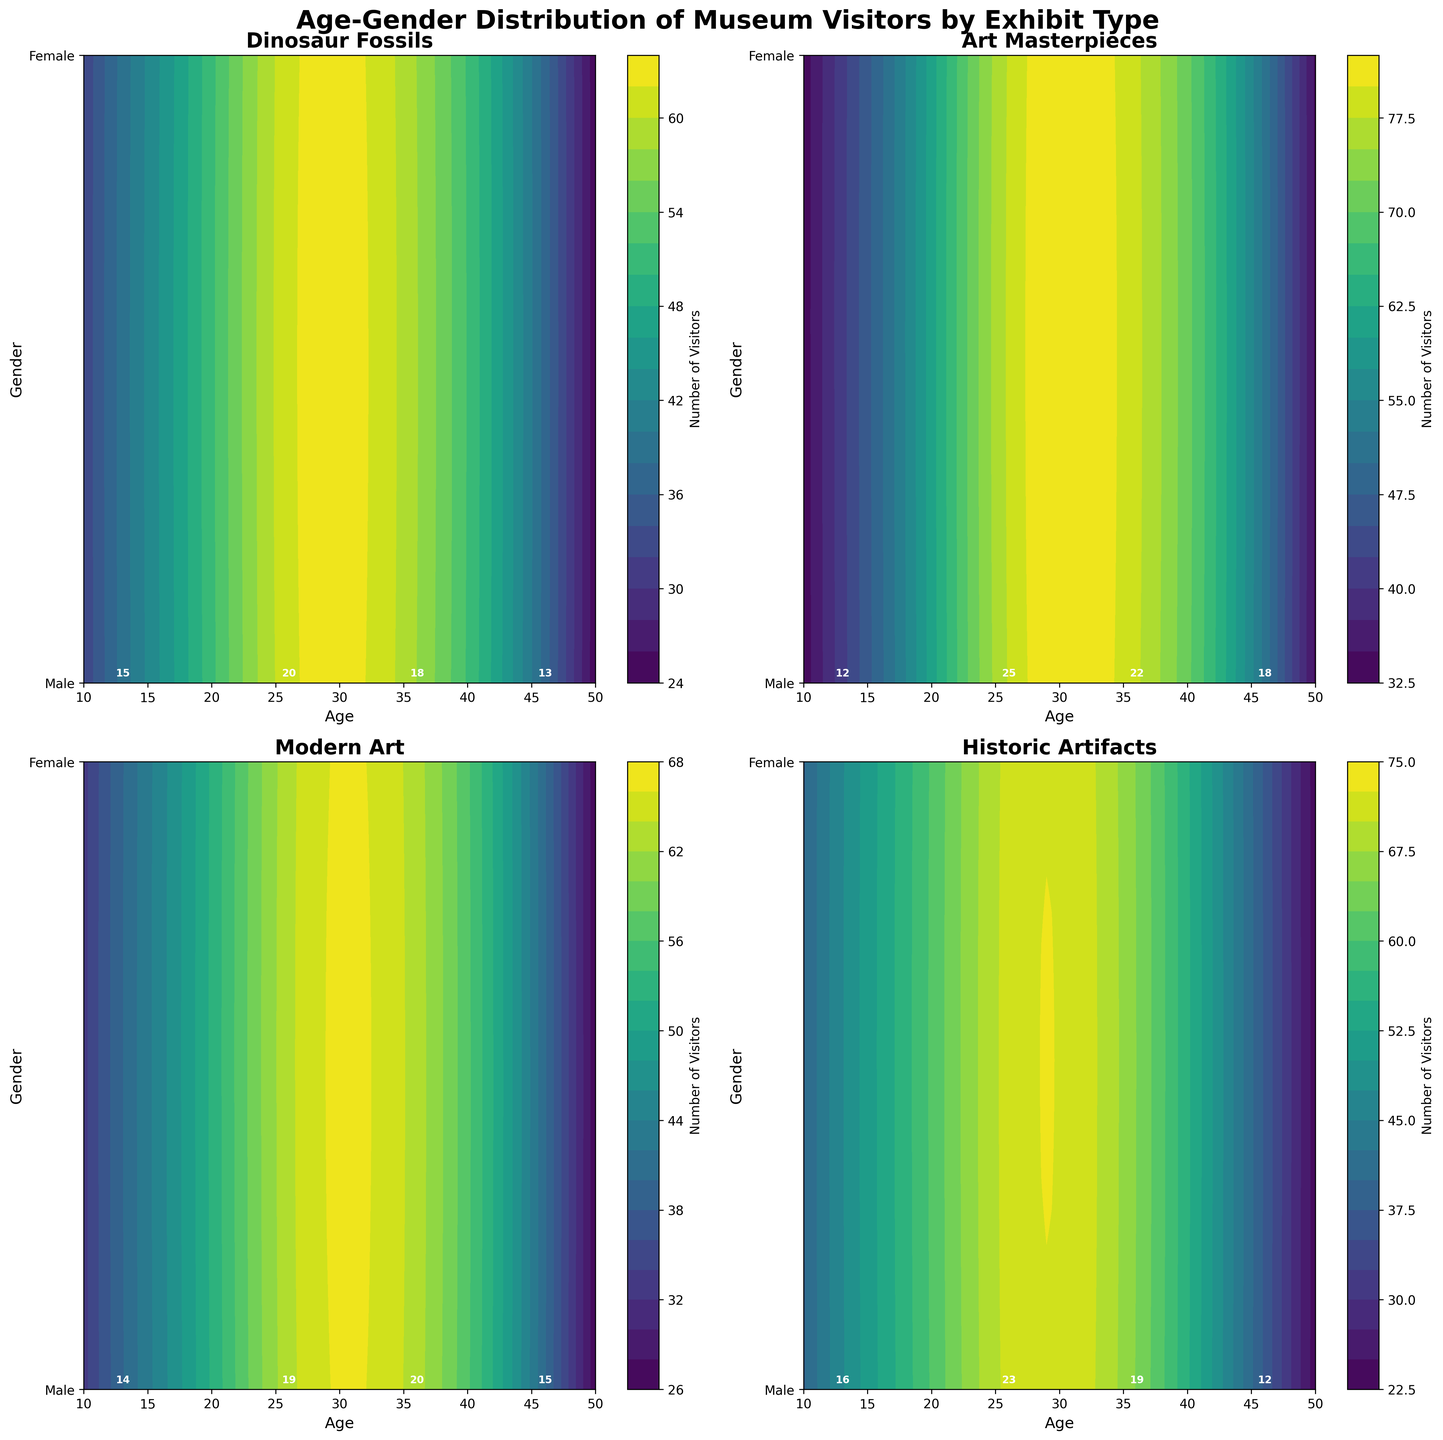What is the title of the plot? The title is located at the top of the figure, clearly stating the main focus.
Answer: Age-Gender Distribution of Museum Visitors by Exhibit Type How many exhibit types are represented in the figure? Each subplot represents a different exhibit type. Counting the titles of each subplot reveals the number of exhibit types.
Answer: 4 What is the color scheme used for the contour plots? The contour plots are colored using a sequential color map, easily identified by observing the gradient from low to high visitor numbers.
Answer: Viridis Which exhibit has the highest number of visitors for females at age 25? Look for the highest contour levels and labels near the point where age is 25 and gender is Female (represented by 1) across all subplots.
Answer: Art Masterpieces How does the number of male visitors aged 35 for the Dinosaur Fossils exhibit compare to the number of female visitors of the same age and exhibit? Check the contour labels at age 35 and gender 0 (Male) versus gender 1 (Female) within the Dinosaur Fossils subplot.
Answer: 18 (Male) vs 16 (Female) Which exhibit has the most balanced age distribution of visitors based on the contour spread? Observe the contours' spread along the age axis for each subplot. A more even spread indicates a balanced age distribution.
Answer: Art Masterpieces What is the difference in the number of visitors between males aged 12 and females aged 12 for the Historic Artifacts exhibit? Identify the visitor numbers at age 12 for both genders within the Historic Artifacts subplot and calculate the difference.
Answer: 4 (20 Female - 16 Male) What general trend can be observed about the gender distribution of visitors for the Modern Art exhibit? Look for contour patterns and labels in the Modern Art subplot, considering the visitor distribution between gender values 0 and 1.
Answer: More balanced or slightly more females Across exhibits, which age group appears most frequently as the peak visitor age? Identify the age points with the highest contour levels or visitor numbers across all subplots.
Answer: 25 